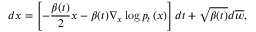<formula> <loc_0><loc_0><loc_500><loc_500>d x = \left [ - \frac { \beta ( t ) } { 2 } x - \beta ( t ) \nabla _ { x } \log p _ { t } \left ( x \right ) \right ] d t + \sqrt { \beta ( t ) } d \overline { w } ,</formula> 